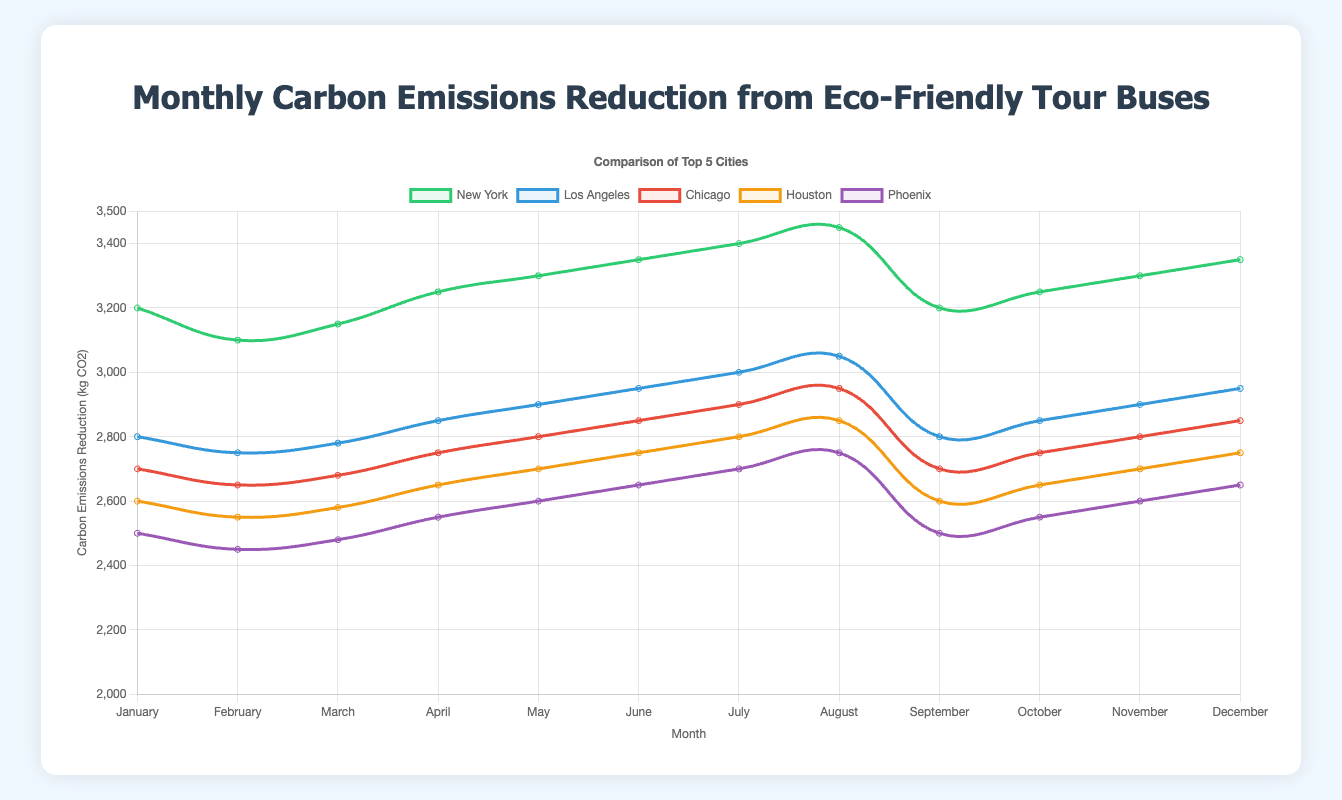What is the total carbon emissions reduction for New York and Los Angeles in July combined? To find the total reduction for both cities in July, add the values for New York and Los Angeles in July. New York’s reduction is 3400 kg CO2 and Los Angeles’ reduction is 3000 kg CO2. The combined reduction is 3400 + 3000 = 6400 kg CO2.
Answer: 6400 kg CO2 Which city had the highest carbon emissions reduction in April? Look at the line graph for April and compare the reductions for all cities. New York had the highest reduction of 3250 kg CO2 in April.
Answer: New York By how much did the carbon emissions reduction in Chicago increase from February to March? To find the increase, subtract the February value for Chicago from the March value for Chicago. The reduction in February was 2650 kg CO2, and in March, it was 2680 kg CO2. The increase is 2680 - 2650 = 30 kg CO2.
Answer: 30 kg CO2 Which city had the lowest carbon emissions reduction in June? Look at the line graph for June and find the city with the lowest reduction. San Jose had the lowest reduction at 2250 kg CO2 in June.
Answer: San Jose How does the trend in carbon emissions reduction for Phoenix compare to that of San Antonio from January to August? From January to August, both Phoenix and San Antonio show a consistent increase in carbon emissions reduction each month. Phoenix’s trend increases from 2500 to 2750 kg CO2, and San Antonio’s trend increases from 2300 to 2500 kg CO2. While both show an increasing trend, Phoenix has a slightly higher reduction overall compared to San Antonio.
Answer: Both increase, Phoenix higher What was the average carbon emissions reduction for Los Angeles from March to June? To find the average reduction for Los Angeles from March to June, sum the values from March, April, May, and June and then divide by 4. The values are 2780, 2850, 2900, and 2950 kg CO2. The sum is 2780 + 2850 + 2900 + 2950 = 11480, and the average is 11480 / 4 = 2870 kg CO2.
Answer: 2870 kg CO2 Are the carbon emissions reductions in July the highest for all cities compared to other months? Compare the July reduction values for all cities to their corresponding reductions in other months. For New York, July (3400 kg CO2) is highest. For Los Angeles, July (3000 kg CO2) is highest. For Chicago, July (2900 kg CO2) is highest. For Houston, July (2800 kg CO2) is highest. For Phoenix, July (2700 kg CO2) is highest. Yes, July reductions are the highest for all cities.
Answer: Yes 